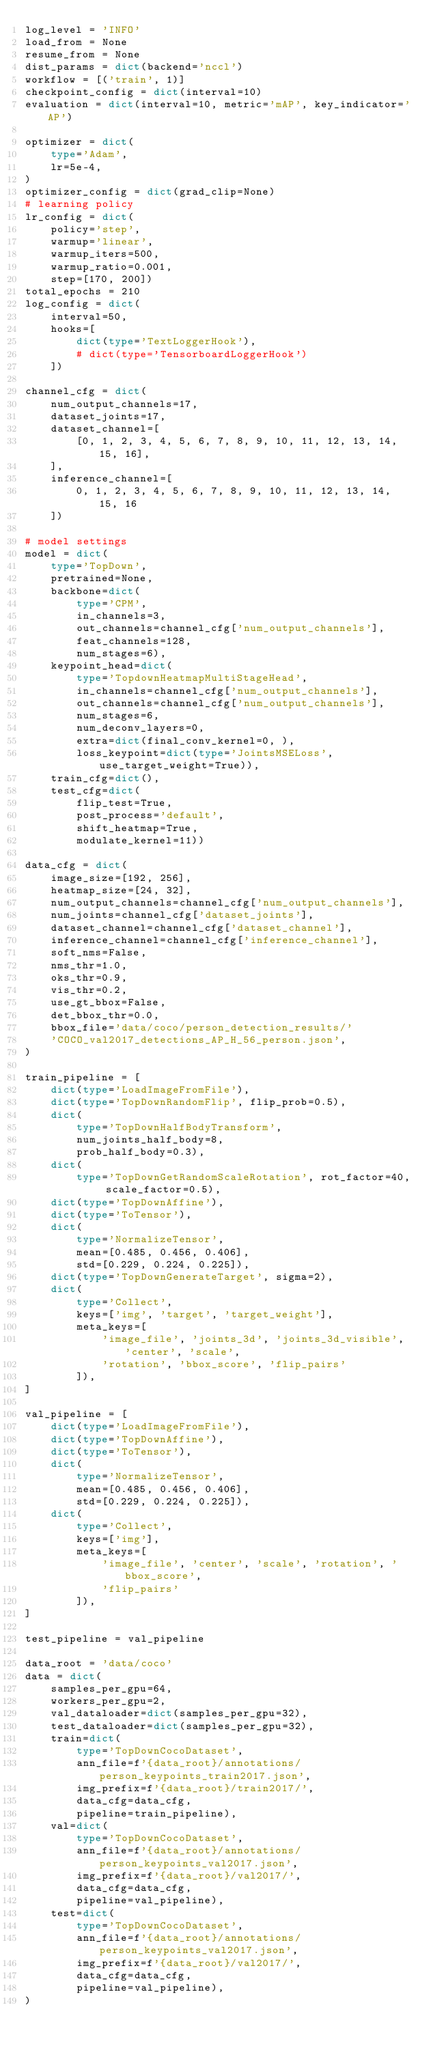Convert code to text. <code><loc_0><loc_0><loc_500><loc_500><_Python_>log_level = 'INFO'
load_from = None
resume_from = None
dist_params = dict(backend='nccl')
workflow = [('train', 1)]
checkpoint_config = dict(interval=10)
evaluation = dict(interval=10, metric='mAP', key_indicator='AP')

optimizer = dict(
    type='Adam',
    lr=5e-4,
)
optimizer_config = dict(grad_clip=None)
# learning policy
lr_config = dict(
    policy='step',
    warmup='linear',
    warmup_iters=500,
    warmup_ratio=0.001,
    step=[170, 200])
total_epochs = 210
log_config = dict(
    interval=50,
    hooks=[
        dict(type='TextLoggerHook'),
        # dict(type='TensorboardLoggerHook')
    ])

channel_cfg = dict(
    num_output_channels=17,
    dataset_joints=17,
    dataset_channel=[
        [0, 1, 2, 3, 4, 5, 6, 7, 8, 9, 10, 11, 12, 13, 14, 15, 16],
    ],
    inference_channel=[
        0, 1, 2, 3, 4, 5, 6, 7, 8, 9, 10, 11, 12, 13, 14, 15, 16
    ])

# model settings
model = dict(
    type='TopDown',
    pretrained=None,
    backbone=dict(
        type='CPM',
        in_channels=3,
        out_channels=channel_cfg['num_output_channels'],
        feat_channels=128,
        num_stages=6),
    keypoint_head=dict(
        type='TopdownHeatmapMultiStageHead',
        in_channels=channel_cfg['num_output_channels'],
        out_channels=channel_cfg['num_output_channels'],
        num_stages=6,
        num_deconv_layers=0,
        extra=dict(final_conv_kernel=0, ),
        loss_keypoint=dict(type='JointsMSELoss', use_target_weight=True)),
    train_cfg=dict(),
    test_cfg=dict(
        flip_test=True,
        post_process='default',
        shift_heatmap=True,
        modulate_kernel=11))

data_cfg = dict(
    image_size=[192, 256],
    heatmap_size=[24, 32],
    num_output_channels=channel_cfg['num_output_channels'],
    num_joints=channel_cfg['dataset_joints'],
    dataset_channel=channel_cfg['dataset_channel'],
    inference_channel=channel_cfg['inference_channel'],
    soft_nms=False,
    nms_thr=1.0,
    oks_thr=0.9,
    vis_thr=0.2,
    use_gt_bbox=False,
    det_bbox_thr=0.0,
    bbox_file='data/coco/person_detection_results/'
    'COCO_val2017_detections_AP_H_56_person.json',
)

train_pipeline = [
    dict(type='LoadImageFromFile'),
    dict(type='TopDownRandomFlip', flip_prob=0.5),
    dict(
        type='TopDownHalfBodyTransform',
        num_joints_half_body=8,
        prob_half_body=0.3),
    dict(
        type='TopDownGetRandomScaleRotation', rot_factor=40, scale_factor=0.5),
    dict(type='TopDownAffine'),
    dict(type='ToTensor'),
    dict(
        type='NormalizeTensor',
        mean=[0.485, 0.456, 0.406],
        std=[0.229, 0.224, 0.225]),
    dict(type='TopDownGenerateTarget', sigma=2),
    dict(
        type='Collect',
        keys=['img', 'target', 'target_weight'],
        meta_keys=[
            'image_file', 'joints_3d', 'joints_3d_visible', 'center', 'scale',
            'rotation', 'bbox_score', 'flip_pairs'
        ]),
]

val_pipeline = [
    dict(type='LoadImageFromFile'),
    dict(type='TopDownAffine'),
    dict(type='ToTensor'),
    dict(
        type='NormalizeTensor',
        mean=[0.485, 0.456, 0.406],
        std=[0.229, 0.224, 0.225]),
    dict(
        type='Collect',
        keys=['img'],
        meta_keys=[
            'image_file', 'center', 'scale', 'rotation', 'bbox_score',
            'flip_pairs'
        ]),
]

test_pipeline = val_pipeline

data_root = 'data/coco'
data = dict(
    samples_per_gpu=64,
    workers_per_gpu=2,
    val_dataloader=dict(samples_per_gpu=32),
    test_dataloader=dict(samples_per_gpu=32),
    train=dict(
        type='TopDownCocoDataset',
        ann_file=f'{data_root}/annotations/person_keypoints_train2017.json',
        img_prefix=f'{data_root}/train2017/',
        data_cfg=data_cfg,
        pipeline=train_pipeline),
    val=dict(
        type='TopDownCocoDataset',
        ann_file=f'{data_root}/annotations/person_keypoints_val2017.json',
        img_prefix=f'{data_root}/val2017/',
        data_cfg=data_cfg,
        pipeline=val_pipeline),
    test=dict(
        type='TopDownCocoDataset',
        ann_file=f'{data_root}/annotations/person_keypoints_val2017.json',
        img_prefix=f'{data_root}/val2017/',
        data_cfg=data_cfg,
        pipeline=val_pipeline),
)
</code> 